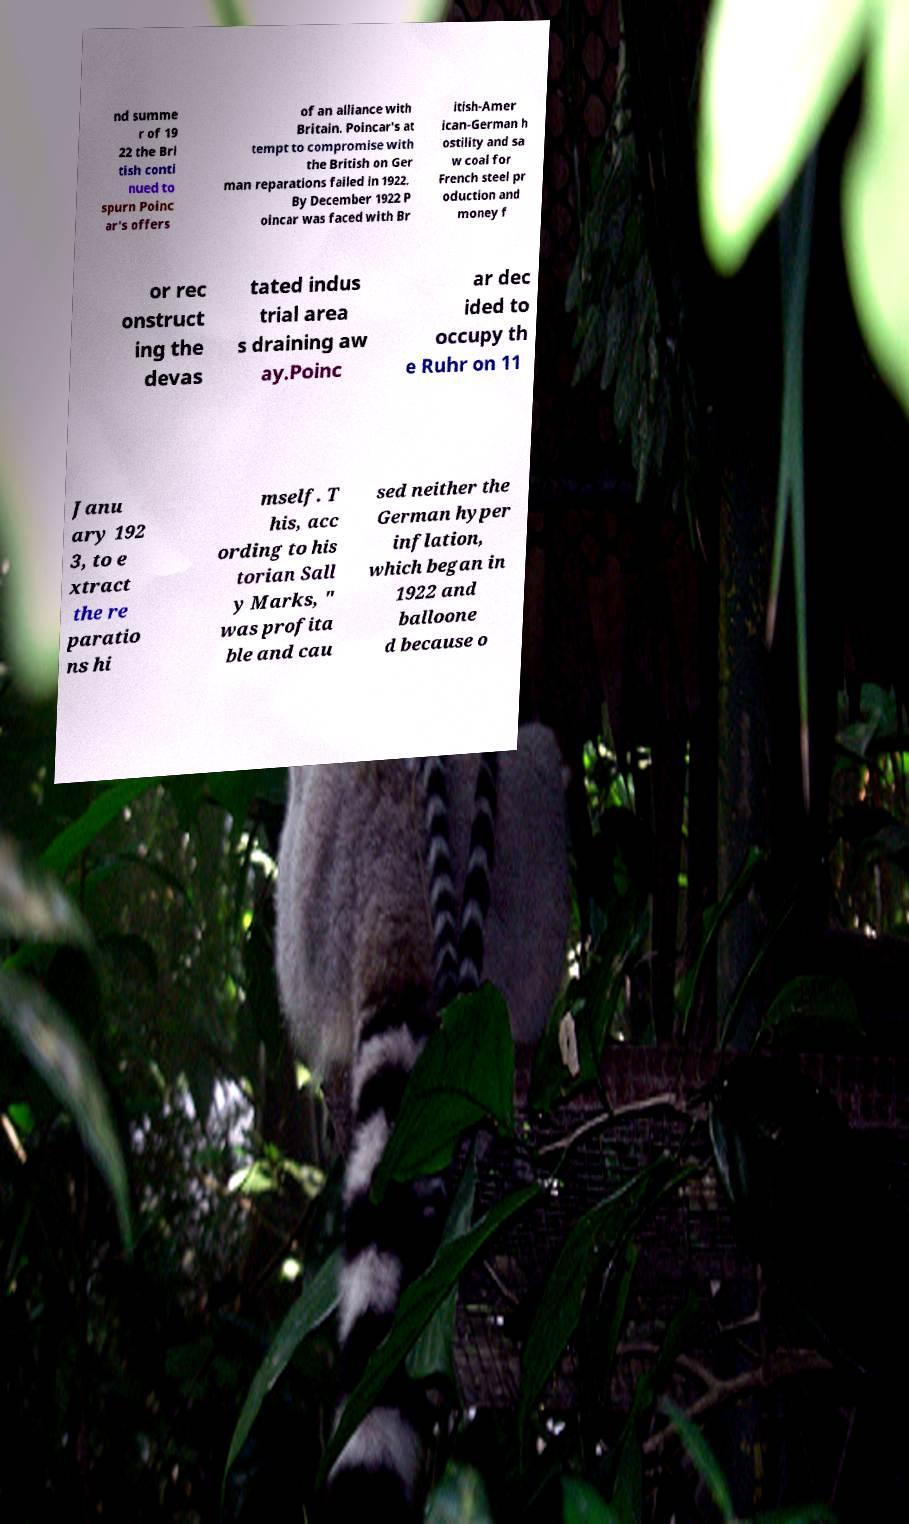Can you accurately transcribe the text from the provided image for me? nd summe r of 19 22 the Bri tish conti nued to spurn Poinc ar's offers of an alliance with Britain. Poincar's at tempt to compromise with the British on Ger man reparations failed in 1922. By December 1922 P oincar was faced with Br itish-Amer ican-German h ostility and sa w coal for French steel pr oduction and money f or rec onstruct ing the devas tated indus trial area s draining aw ay.Poinc ar dec ided to occupy th e Ruhr on 11 Janu ary 192 3, to e xtract the re paratio ns hi mself. T his, acc ording to his torian Sall y Marks, " was profita ble and cau sed neither the German hyper inflation, which began in 1922 and balloone d because o 